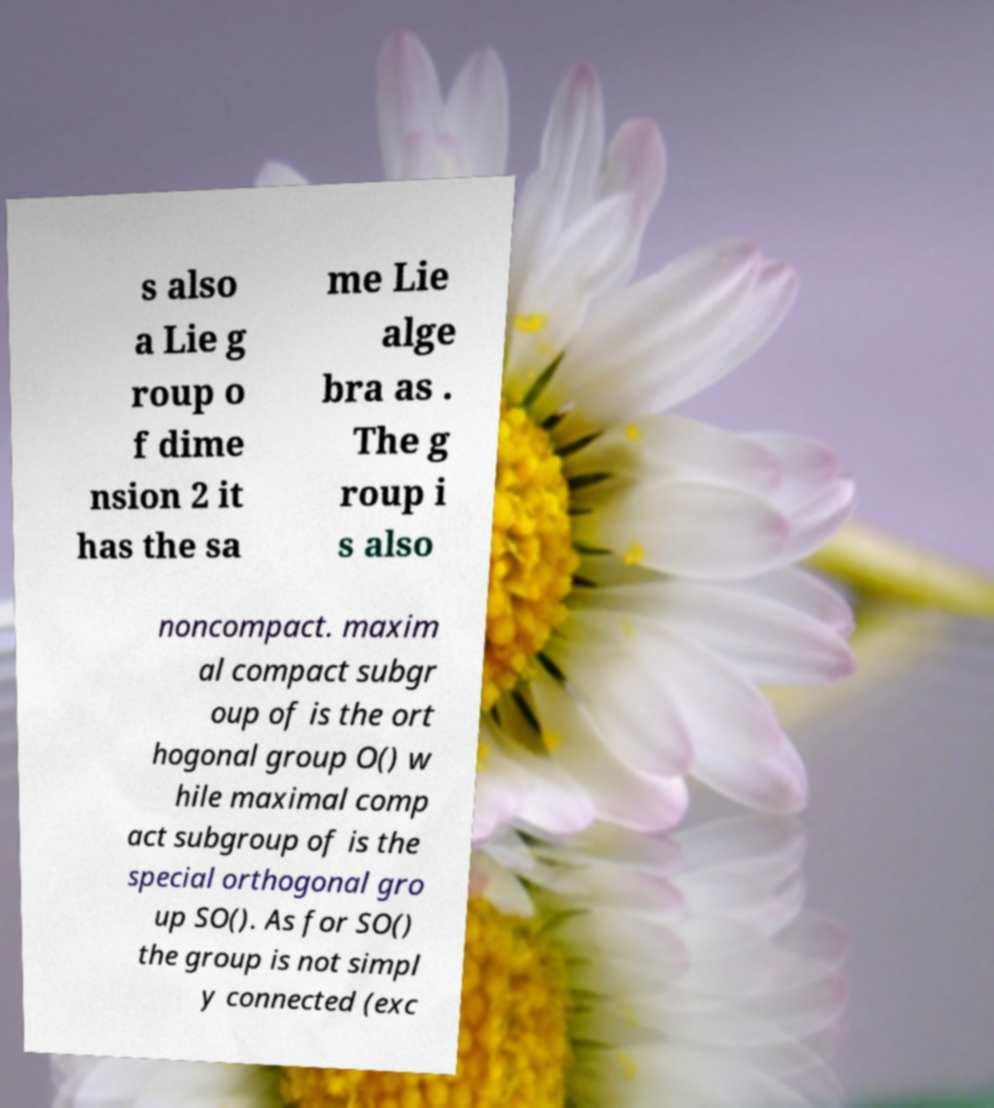Could you assist in decoding the text presented in this image and type it out clearly? s also a Lie g roup o f dime nsion 2 it has the sa me Lie alge bra as . The g roup i s also noncompact. maxim al compact subgr oup of is the ort hogonal group O() w hile maximal comp act subgroup of is the special orthogonal gro up SO(). As for SO() the group is not simpl y connected (exc 